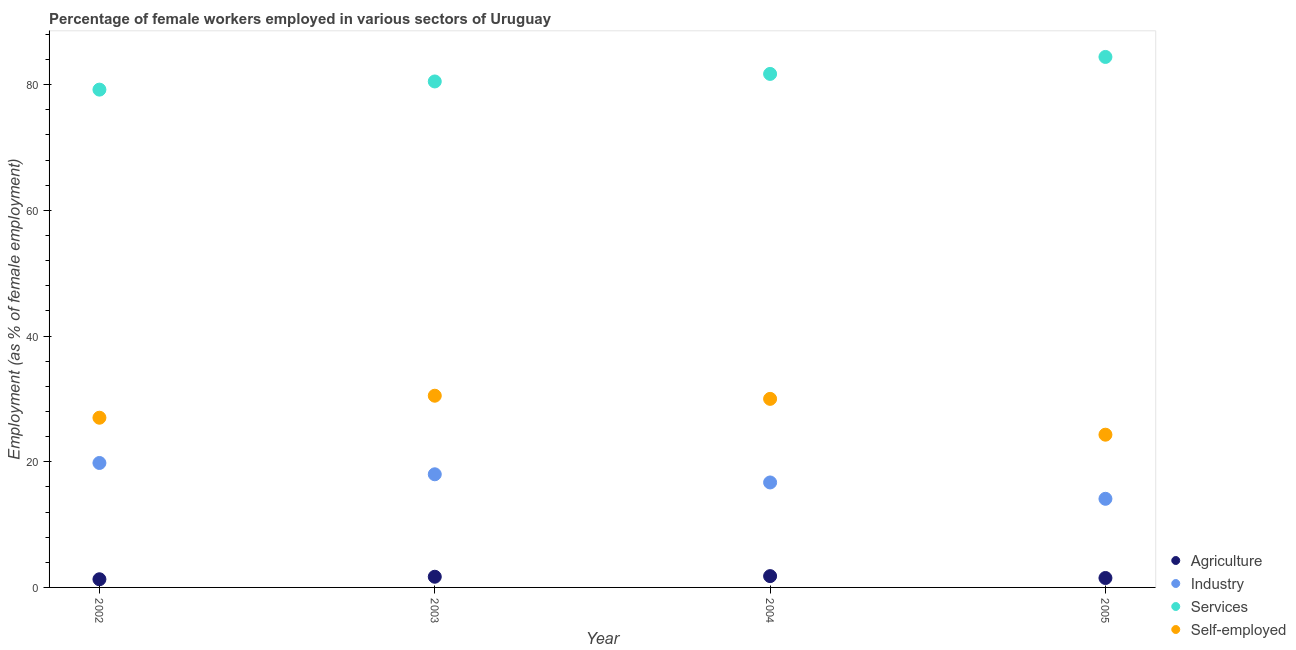How many different coloured dotlines are there?
Provide a short and direct response. 4. Is the number of dotlines equal to the number of legend labels?
Offer a terse response. Yes. What is the percentage of female workers in services in 2002?
Your response must be concise. 79.2. Across all years, what is the maximum percentage of female workers in services?
Ensure brevity in your answer.  84.4. Across all years, what is the minimum percentage of female workers in industry?
Give a very brief answer. 14.1. What is the total percentage of female workers in industry in the graph?
Your response must be concise. 68.6. What is the difference between the percentage of female workers in services in 2002 and that in 2004?
Provide a short and direct response. -2.5. What is the difference between the percentage of self employed female workers in 2003 and the percentage of female workers in services in 2004?
Give a very brief answer. -51.2. What is the average percentage of female workers in services per year?
Offer a very short reply. 81.45. In the year 2002, what is the difference between the percentage of self employed female workers and percentage of female workers in services?
Your answer should be very brief. -52.2. What is the ratio of the percentage of self employed female workers in 2004 to that in 2005?
Give a very brief answer. 1.23. Is the percentage of female workers in agriculture in 2002 less than that in 2003?
Your answer should be very brief. Yes. Is the difference between the percentage of female workers in agriculture in 2004 and 2005 greater than the difference between the percentage of female workers in services in 2004 and 2005?
Offer a terse response. Yes. What is the difference between the highest and the second highest percentage of female workers in industry?
Ensure brevity in your answer.  1.8. What is the difference between the highest and the lowest percentage of female workers in industry?
Your answer should be very brief. 5.7. In how many years, is the percentage of female workers in industry greater than the average percentage of female workers in industry taken over all years?
Ensure brevity in your answer.  2. Is it the case that in every year, the sum of the percentage of female workers in agriculture and percentage of female workers in industry is greater than the percentage of female workers in services?
Keep it short and to the point. No. Is the percentage of self employed female workers strictly greater than the percentage of female workers in services over the years?
Ensure brevity in your answer.  No. Is the percentage of female workers in industry strictly less than the percentage of female workers in agriculture over the years?
Make the answer very short. No. How many dotlines are there?
Offer a terse response. 4. What is the difference between two consecutive major ticks on the Y-axis?
Offer a terse response. 20. Are the values on the major ticks of Y-axis written in scientific E-notation?
Offer a terse response. No. Does the graph contain any zero values?
Provide a short and direct response. No. Where does the legend appear in the graph?
Give a very brief answer. Bottom right. How many legend labels are there?
Provide a succinct answer. 4. How are the legend labels stacked?
Your answer should be very brief. Vertical. What is the title of the graph?
Provide a short and direct response. Percentage of female workers employed in various sectors of Uruguay. What is the label or title of the X-axis?
Provide a succinct answer. Year. What is the label or title of the Y-axis?
Keep it short and to the point. Employment (as % of female employment). What is the Employment (as % of female employment) in Agriculture in 2002?
Provide a succinct answer. 1.3. What is the Employment (as % of female employment) of Industry in 2002?
Make the answer very short. 19.8. What is the Employment (as % of female employment) in Services in 2002?
Give a very brief answer. 79.2. What is the Employment (as % of female employment) of Agriculture in 2003?
Offer a terse response. 1.7. What is the Employment (as % of female employment) of Industry in 2003?
Your answer should be very brief. 18. What is the Employment (as % of female employment) of Services in 2003?
Make the answer very short. 80.5. What is the Employment (as % of female employment) in Self-employed in 2003?
Keep it short and to the point. 30.5. What is the Employment (as % of female employment) of Agriculture in 2004?
Your response must be concise. 1.8. What is the Employment (as % of female employment) in Industry in 2004?
Your response must be concise. 16.7. What is the Employment (as % of female employment) of Services in 2004?
Provide a short and direct response. 81.7. What is the Employment (as % of female employment) in Self-employed in 2004?
Make the answer very short. 30. What is the Employment (as % of female employment) of Industry in 2005?
Provide a succinct answer. 14.1. What is the Employment (as % of female employment) in Services in 2005?
Your answer should be very brief. 84.4. What is the Employment (as % of female employment) in Self-employed in 2005?
Offer a very short reply. 24.3. Across all years, what is the maximum Employment (as % of female employment) in Agriculture?
Offer a very short reply. 1.8. Across all years, what is the maximum Employment (as % of female employment) in Industry?
Offer a terse response. 19.8. Across all years, what is the maximum Employment (as % of female employment) of Services?
Offer a very short reply. 84.4. Across all years, what is the maximum Employment (as % of female employment) in Self-employed?
Your answer should be compact. 30.5. Across all years, what is the minimum Employment (as % of female employment) in Agriculture?
Your response must be concise. 1.3. Across all years, what is the minimum Employment (as % of female employment) in Industry?
Offer a terse response. 14.1. Across all years, what is the minimum Employment (as % of female employment) in Services?
Ensure brevity in your answer.  79.2. Across all years, what is the minimum Employment (as % of female employment) of Self-employed?
Keep it short and to the point. 24.3. What is the total Employment (as % of female employment) in Industry in the graph?
Offer a terse response. 68.6. What is the total Employment (as % of female employment) of Services in the graph?
Give a very brief answer. 325.8. What is the total Employment (as % of female employment) in Self-employed in the graph?
Make the answer very short. 111.8. What is the difference between the Employment (as % of female employment) of Agriculture in 2002 and that in 2003?
Provide a succinct answer. -0.4. What is the difference between the Employment (as % of female employment) of Industry in 2002 and that in 2003?
Make the answer very short. 1.8. What is the difference between the Employment (as % of female employment) in Industry in 2002 and that in 2005?
Provide a short and direct response. 5.7. What is the difference between the Employment (as % of female employment) of Agriculture in 2003 and that in 2004?
Make the answer very short. -0.1. What is the difference between the Employment (as % of female employment) of Industry in 2003 and that in 2004?
Ensure brevity in your answer.  1.3. What is the difference between the Employment (as % of female employment) of Services in 2003 and that in 2005?
Make the answer very short. -3.9. What is the difference between the Employment (as % of female employment) in Agriculture in 2004 and that in 2005?
Offer a terse response. 0.3. What is the difference between the Employment (as % of female employment) of Industry in 2004 and that in 2005?
Your answer should be compact. 2.6. What is the difference between the Employment (as % of female employment) in Self-employed in 2004 and that in 2005?
Your answer should be very brief. 5.7. What is the difference between the Employment (as % of female employment) in Agriculture in 2002 and the Employment (as % of female employment) in Industry in 2003?
Offer a very short reply. -16.7. What is the difference between the Employment (as % of female employment) in Agriculture in 2002 and the Employment (as % of female employment) in Services in 2003?
Ensure brevity in your answer.  -79.2. What is the difference between the Employment (as % of female employment) of Agriculture in 2002 and the Employment (as % of female employment) of Self-employed in 2003?
Your response must be concise. -29.2. What is the difference between the Employment (as % of female employment) in Industry in 2002 and the Employment (as % of female employment) in Services in 2003?
Your response must be concise. -60.7. What is the difference between the Employment (as % of female employment) in Industry in 2002 and the Employment (as % of female employment) in Self-employed in 2003?
Make the answer very short. -10.7. What is the difference between the Employment (as % of female employment) of Services in 2002 and the Employment (as % of female employment) of Self-employed in 2003?
Provide a succinct answer. 48.7. What is the difference between the Employment (as % of female employment) in Agriculture in 2002 and the Employment (as % of female employment) in Industry in 2004?
Ensure brevity in your answer.  -15.4. What is the difference between the Employment (as % of female employment) of Agriculture in 2002 and the Employment (as % of female employment) of Services in 2004?
Your response must be concise. -80.4. What is the difference between the Employment (as % of female employment) in Agriculture in 2002 and the Employment (as % of female employment) in Self-employed in 2004?
Your answer should be very brief. -28.7. What is the difference between the Employment (as % of female employment) in Industry in 2002 and the Employment (as % of female employment) in Services in 2004?
Ensure brevity in your answer.  -61.9. What is the difference between the Employment (as % of female employment) in Industry in 2002 and the Employment (as % of female employment) in Self-employed in 2004?
Keep it short and to the point. -10.2. What is the difference between the Employment (as % of female employment) in Services in 2002 and the Employment (as % of female employment) in Self-employed in 2004?
Ensure brevity in your answer.  49.2. What is the difference between the Employment (as % of female employment) of Agriculture in 2002 and the Employment (as % of female employment) of Services in 2005?
Provide a short and direct response. -83.1. What is the difference between the Employment (as % of female employment) in Agriculture in 2002 and the Employment (as % of female employment) in Self-employed in 2005?
Your response must be concise. -23. What is the difference between the Employment (as % of female employment) of Industry in 2002 and the Employment (as % of female employment) of Services in 2005?
Offer a very short reply. -64.6. What is the difference between the Employment (as % of female employment) in Industry in 2002 and the Employment (as % of female employment) in Self-employed in 2005?
Offer a terse response. -4.5. What is the difference between the Employment (as % of female employment) in Services in 2002 and the Employment (as % of female employment) in Self-employed in 2005?
Offer a terse response. 54.9. What is the difference between the Employment (as % of female employment) in Agriculture in 2003 and the Employment (as % of female employment) in Services in 2004?
Your answer should be very brief. -80. What is the difference between the Employment (as % of female employment) in Agriculture in 2003 and the Employment (as % of female employment) in Self-employed in 2004?
Keep it short and to the point. -28.3. What is the difference between the Employment (as % of female employment) in Industry in 2003 and the Employment (as % of female employment) in Services in 2004?
Make the answer very short. -63.7. What is the difference between the Employment (as % of female employment) in Services in 2003 and the Employment (as % of female employment) in Self-employed in 2004?
Offer a terse response. 50.5. What is the difference between the Employment (as % of female employment) of Agriculture in 2003 and the Employment (as % of female employment) of Industry in 2005?
Provide a succinct answer. -12.4. What is the difference between the Employment (as % of female employment) of Agriculture in 2003 and the Employment (as % of female employment) of Services in 2005?
Provide a succinct answer. -82.7. What is the difference between the Employment (as % of female employment) in Agriculture in 2003 and the Employment (as % of female employment) in Self-employed in 2005?
Provide a short and direct response. -22.6. What is the difference between the Employment (as % of female employment) in Industry in 2003 and the Employment (as % of female employment) in Services in 2005?
Offer a very short reply. -66.4. What is the difference between the Employment (as % of female employment) of Industry in 2003 and the Employment (as % of female employment) of Self-employed in 2005?
Provide a succinct answer. -6.3. What is the difference between the Employment (as % of female employment) in Services in 2003 and the Employment (as % of female employment) in Self-employed in 2005?
Give a very brief answer. 56.2. What is the difference between the Employment (as % of female employment) in Agriculture in 2004 and the Employment (as % of female employment) in Industry in 2005?
Offer a very short reply. -12.3. What is the difference between the Employment (as % of female employment) of Agriculture in 2004 and the Employment (as % of female employment) of Services in 2005?
Provide a short and direct response. -82.6. What is the difference between the Employment (as % of female employment) of Agriculture in 2004 and the Employment (as % of female employment) of Self-employed in 2005?
Offer a very short reply. -22.5. What is the difference between the Employment (as % of female employment) in Industry in 2004 and the Employment (as % of female employment) in Services in 2005?
Your response must be concise. -67.7. What is the difference between the Employment (as % of female employment) of Industry in 2004 and the Employment (as % of female employment) of Self-employed in 2005?
Offer a very short reply. -7.6. What is the difference between the Employment (as % of female employment) of Services in 2004 and the Employment (as % of female employment) of Self-employed in 2005?
Ensure brevity in your answer.  57.4. What is the average Employment (as % of female employment) in Agriculture per year?
Ensure brevity in your answer.  1.57. What is the average Employment (as % of female employment) of Industry per year?
Keep it short and to the point. 17.15. What is the average Employment (as % of female employment) of Services per year?
Provide a short and direct response. 81.45. What is the average Employment (as % of female employment) in Self-employed per year?
Make the answer very short. 27.95. In the year 2002, what is the difference between the Employment (as % of female employment) of Agriculture and Employment (as % of female employment) of Industry?
Your response must be concise. -18.5. In the year 2002, what is the difference between the Employment (as % of female employment) of Agriculture and Employment (as % of female employment) of Services?
Provide a short and direct response. -77.9. In the year 2002, what is the difference between the Employment (as % of female employment) of Agriculture and Employment (as % of female employment) of Self-employed?
Ensure brevity in your answer.  -25.7. In the year 2002, what is the difference between the Employment (as % of female employment) in Industry and Employment (as % of female employment) in Services?
Offer a terse response. -59.4. In the year 2002, what is the difference between the Employment (as % of female employment) of Industry and Employment (as % of female employment) of Self-employed?
Keep it short and to the point. -7.2. In the year 2002, what is the difference between the Employment (as % of female employment) in Services and Employment (as % of female employment) in Self-employed?
Offer a very short reply. 52.2. In the year 2003, what is the difference between the Employment (as % of female employment) of Agriculture and Employment (as % of female employment) of Industry?
Ensure brevity in your answer.  -16.3. In the year 2003, what is the difference between the Employment (as % of female employment) of Agriculture and Employment (as % of female employment) of Services?
Offer a very short reply. -78.8. In the year 2003, what is the difference between the Employment (as % of female employment) in Agriculture and Employment (as % of female employment) in Self-employed?
Give a very brief answer. -28.8. In the year 2003, what is the difference between the Employment (as % of female employment) of Industry and Employment (as % of female employment) of Services?
Give a very brief answer. -62.5. In the year 2004, what is the difference between the Employment (as % of female employment) in Agriculture and Employment (as % of female employment) in Industry?
Make the answer very short. -14.9. In the year 2004, what is the difference between the Employment (as % of female employment) of Agriculture and Employment (as % of female employment) of Services?
Provide a short and direct response. -79.9. In the year 2004, what is the difference between the Employment (as % of female employment) in Agriculture and Employment (as % of female employment) in Self-employed?
Your answer should be compact. -28.2. In the year 2004, what is the difference between the Employment (as % of female employment) in Industry and Employment (as % of female employment) in Services?
Give a very brief answer. -65. In the year 2004, what is the difference between the Employment (as % of female employment) of Services and Employment (as % of female employment) of Self-employed?
Offer a terse response. 51.7. In the year 2005, what is the difference between the Employment (as % of female employment) in Agriculture and Employment (as % of female employment) in Services?
Your response must be concise. -82.9. In the year 2005, what is the difference between the Employment (as % of female employment) of Agriculture and Employment (as % of female employment) of Self-employed?
Your answer should be compact. -22.8. In the year 2005, what is the difference between the Employment (as % of female employment) in Industry and Employment (as % of female employment) in Services?
Offer a terse response. -70.3. In the year 2005, what is the difference between the Employment (as % of female employment) of Services and Employment (as % of female employment) of Self-employed?
Your response must be concise. 60.1. What is the ratio of the Employment (as % of female employment) in Agriculture in 2002 to that in 2003?
Give a very brief answer. 0.76. What is the ratio of the Employment (as % of female employment) in Industry in 2002 to that in 2003?
Ensure brevity in your answer.  1.1. What is the ratio of the Employment (as % of female employment) of Services in 2002 to that in 2003?
Keep it short and to the point. 0.98. What is the ratio of the Employment (as % of female employment) of Self-employed in 2002 to that in 2003?
Give a very brief answer. 0.89. What is the ratio of the Employment (as % of female employment) in Agriculture in 2002 to that in 2004?
Make the answer very short. 0.72. What is the ratio of the Employment (as % of female employment) in Industry in 2002 to that in 2004?
Make the answer very short. 1.19. What is the ratio of the Employment (as % of female employment) in Services in 2002 to that in 2004?
Make the answer very short. 0.97. What is the ratio of the Employment (as % of female employment) of Agriculture in 2002 to that in 2005?
Your response must be concise. 0.87. What is the ratio of the Employment (as % of female employment) of Industry in 2002 to that in 2005?
Keep it short and to the point. 1.4. What is the ratio of the Employment (as % of female employment) of Services in 2002 to that in 2005?
Offer a very short reply. 0.94. What is the ratio of the Employment (as % of female employment) in Self-employed in 2002 to that in 2005?
Offer a very short reply. 1.11. What is the ratio of the Employment (as % of female employment) of Agriculture in 2003 to that in 2004?
Offer a very short reply. 0.94. What is the ratio of the Employment (as % of female employment) of Industry in 2003 to that in 2004?
Offer a very short reply. 1.08. What is the ratio of the Employment (as % of female employment) in Services in 2003 to that in 2004?
Your answer should be very brief. 0.99. What is the ratio of the Employment (as % of female employment) of Self-employed in 2003 to that in 2004?
Make the answer very short. 1.02. What is the ratio of the Employment (as % of female employment) in Agriculture in 2003 to that in 2005?
Keep it short and to the point. 1.13. What is the ratio of the Employment (as % of female employment) in Industry in 2003 to that in 2005?
Make the answer very short. 1.28. What is the ratio of the Employment (as % of female employment) in Services in 2003 to that in 2005?
Keep it short and to the point. 0.95. What is the ratio of the Employment (as % of female employment) of Self-employed in 2003 to that in 2005?
Your answer should be very brief. 1.26. What is the ratio of the Employment (as % of female employment) of Industry in 2004 to that in 2005?
Make the answer very short. 1.18. What is the ratio of the Employment (as % of female employment) of Services in 2004 to that in 2005?
Ensure brevity in your answer.  0.97. What is the ratio of the Employment (as % of female employment) of Self-employed in 2004 to that in 2005?
Give a very brief answer. 1.23. What is the difference between the highest and the lowest Employment (as % of female employment) in Agriculture?
Offer a very short reply. 0.5. What is the difference between the highest and the lowest Employment (as % of female employment) in Self-employed?
Your response must be concise. 6.2. 